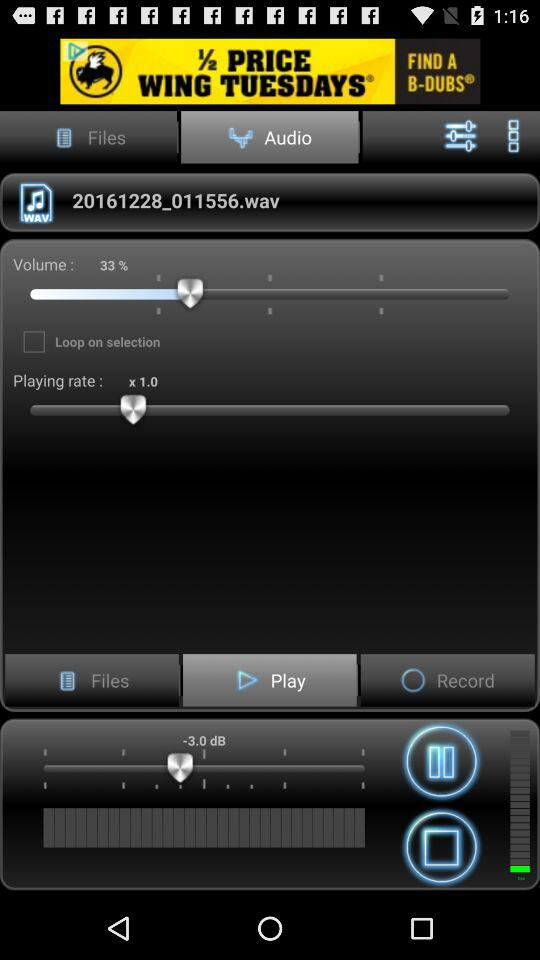What's the value in DB? The value in DB is -3.0. 